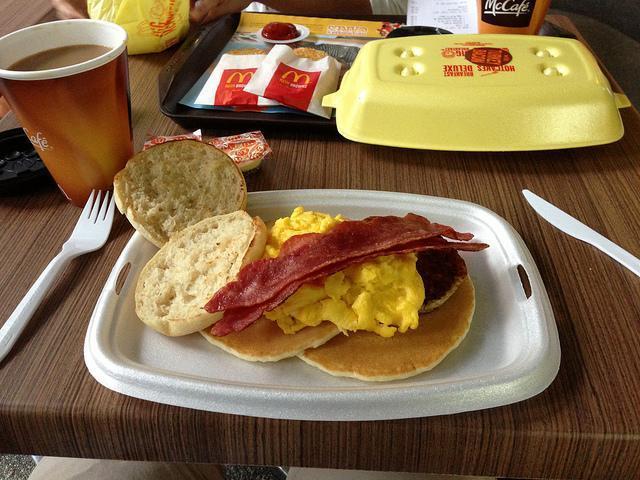How many cups are in the picture?
Give a very brief answer. 2. 